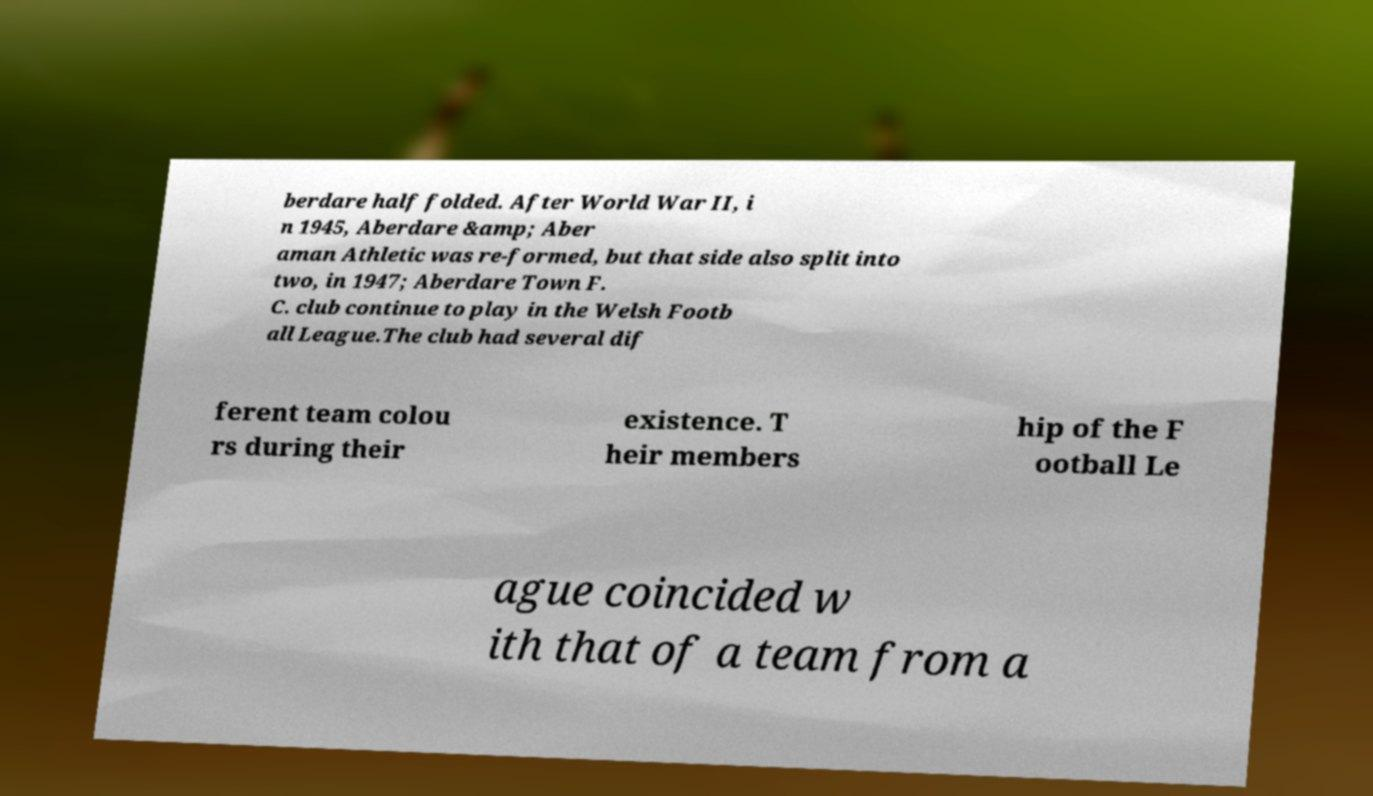Can you read and provide the text displayed in the image?This photo seems to have some interesting text. Can you extract and type it out for me? berdare half folded. After World War II, i n 1945, Aberdare &amp; Aber aman Athletic was re-formed, but that side also split into two, in 1947; Aberdare Town F. C. club continue to play in the Welsh Footb all League.The club had several dif ferent team colou rs during their existence. T heir members hip of the F ootball Le ague coincided w ith that of a team from a 